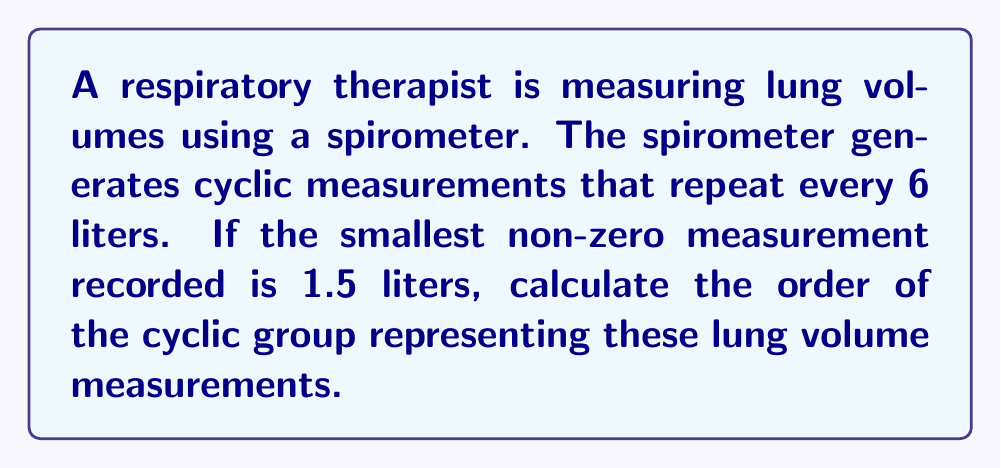Show me your answer to this math problem. Let's approach this step-by-step:

1) First, we need to understand what the cyclic group represents in this context:
   - The group elements are the possible lung volume measurements.
   - The group operation is addition modulo 6 (since the measurements repeat every 6 liters).

2) To find the order of the group, we need to determine how many distinct elements are in the group before it repeats.

3) We can generate the elements of the group starting from the smallest non-zero measurement (1.5 liters):

   $$1.5, 3.0, 4.5, 6.0 \equiv 0, 1.5, 3.0, ...$$

4) We see that after four steps, we're back to 1.5, and the cycle repeats.

5) In group theory terms, we can express this as:

   $$\langle 1.5 \rangle = \{1.5, 3.0, 4.5, 0\}$$

   Where $\langle 1.5 \rangle$ denotes the cyclic group generated by 1.5.

6) The order of a cyclic group is the number of distinct elements before the group repeats.

7) In this case, we have 4 distinct elements: 1.5, 3.0, 4.5, and 0.

Therefore, the order of the cyclic group is 4.
Answer: The order of the cyclic group is 4. 